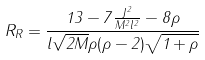<formula> <loc_0><loc_0><loc_500><loc_500>R _ { R } = \frac { 1 3 - 7 \frac { J ^ { 2 } } { M ^ { 2 } l ^ { 2 } } - 8 \rho } { l \sqrt { 2 M } \rho ( \rho - 2 ) \sqrt { 1 + \rho } }</formula> 